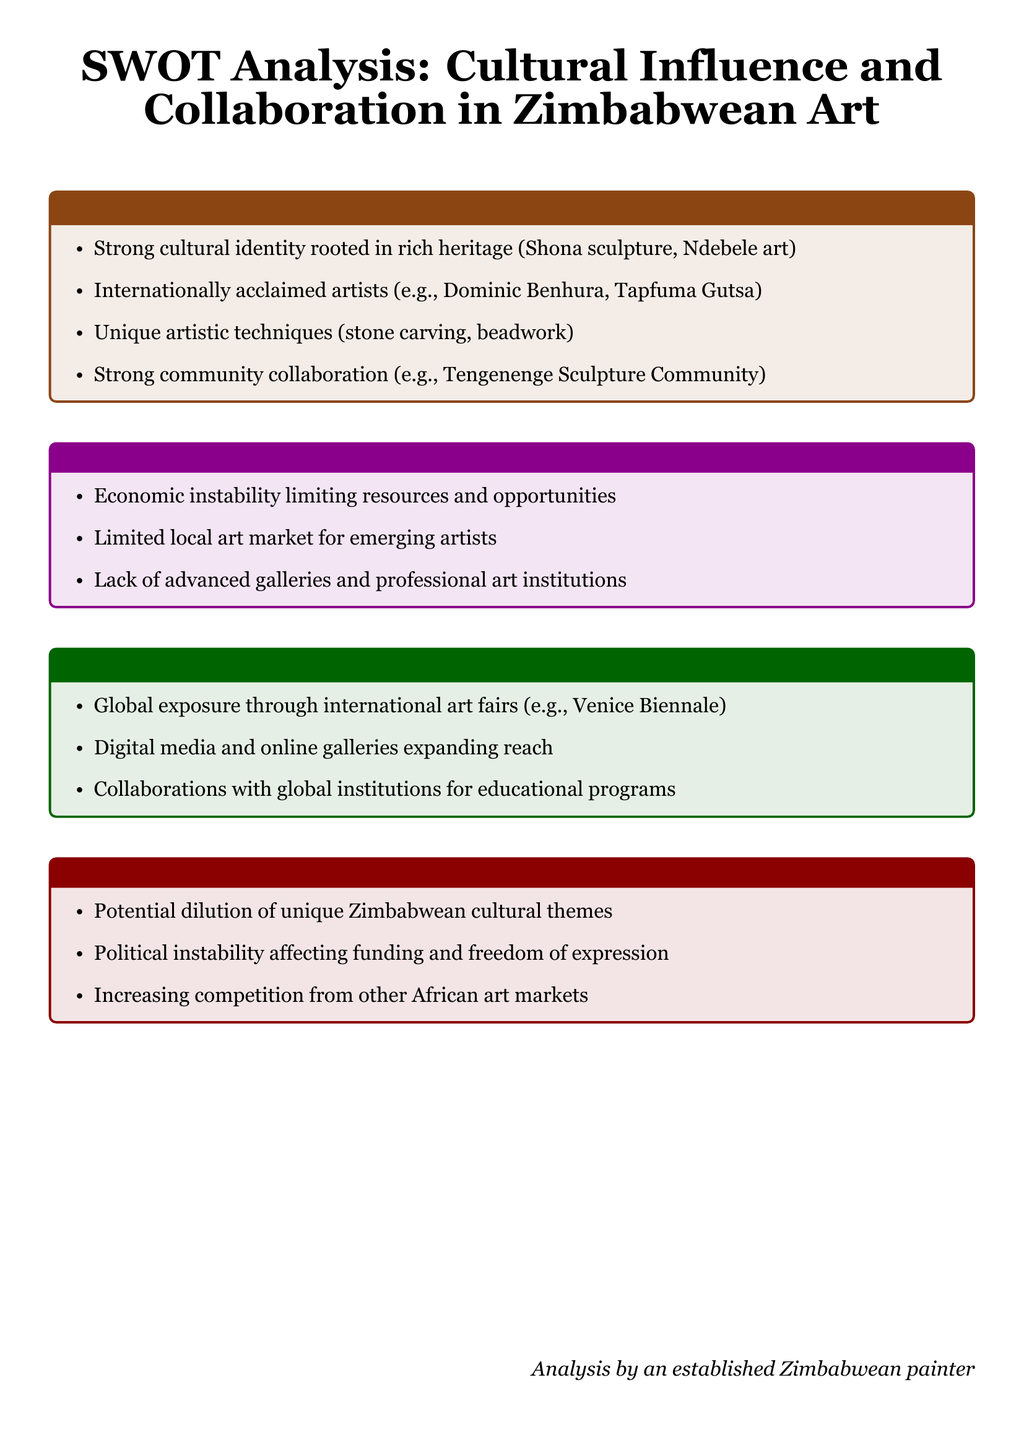What are two strong cultural identities mentioned? The document lists Shona sculpture and Ndebele art as strong cultural identities.
Answer: Shona sculpture, Ndebele art Who is an internationally acclaimed artist mentioned? The document cites Dominic Benhura as an internationally acclaimed artist.
Answer: Dominic Benhura What is identified as a weakness in Zimbabwean art? Economic instability is mentioned as a weakness limiting resources and opportunities.
Answer: Economic instability Name one opportunity for Zimbabwean artists noted in the document. The document mentions global exposure through international art fairs as an opportunity.
Answer: Global exposure through international art fairs What threat is associated with political instability? The threat associated with political instability is affecting funding and freedom of expression.
Answer: Affecting funding and freedom of expression Which community collaboration is highlighted as a strength? The Tengenenge Sculpture Community is highlighted as a strong community collaboration.
Answer: Tengenenge Sculpture Community What unique artistic technique is noted in the strengths section? Stone carving is noted as a unique artistic technique in the strengths.
Answer: Stone carving How many weaknesses are listed in the document? The document lists three weaknesses in total.
Answer: Three What is a potential threat regarding cultural themes? The document states the potential dilution of unique Zimbabwean cultural themes as a threat.
Answer: Potential dilution of unique Zimbabwean cultural themes 